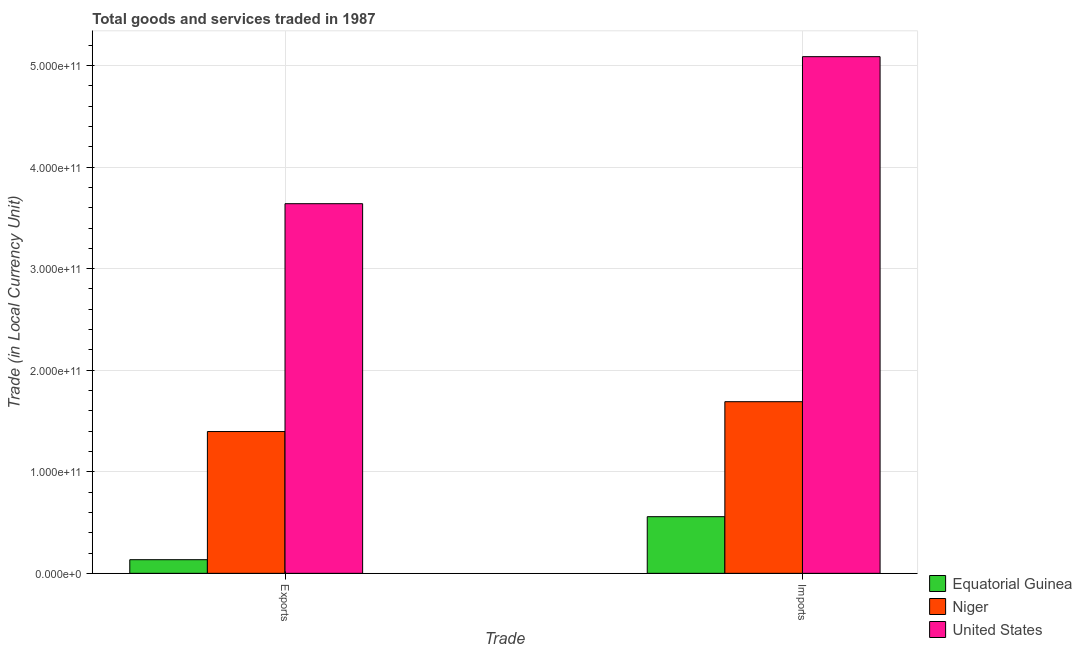Are the number of bars per tick equal to the number of legend labels?
Make the answer very short. Yes. Are the number of bars on each tick of the X-axis equal?
Offer a very short reply. Yes. How many bars are there on the 1st tick from the left?
Give a very brief answer. 3. How many bars are there on the 2nd tick from the right?
Ensure brevity in your answer.  3. What is the label of the 2nd group of bars from the left?
Your response must be concise. Imports. What is the imports of goods and services in United States?
Offer a very short reply. 5.09e+11. Across all countries, what is the maximum export of goods and services?
Provide a short and direct response. 3.64e+11. Across all countries, what is the minimum export of goods and services?
Your response must be concise. 1.34e+1. In which country was the imports of goods and services maximum?
Your answer should be compact. United States. In which country was the imports of goods and services minimum?
Offer a terse response. Equatorial Guinea. What is the total imports of goods and services in the graph?
Your answer should be compact. 7.33e+11. What is the difference between the export of goods and services in Equatorial Guinea and that in United States?
Provide a succinct answer. -3.51e+11. What is the difference between the export of goods and services in Equatorial Guinea and the imports of goods and services in Niger?
Make the answer very short. -1.56e+11. What is the average imports of goods and services per country?
Provide a succinct answer. 2.44e+11. What is the difference between the imports of goods and services and export of goods and services in United States?
Your answer should be compact. 1.45e+11. What is the ratio of the export of goods and services in Equatorial Guinea to that in Niger?
Your response must be concise. 0.1. Is the imports of goods and services in United States less than that in Niger?
Offer a terse response. No. In how many countries, is the export of goods and services greater than the average export of goods and services taken over all countries?
Provide a succinct answer. 1. What does the 1st bar from the left in Exports represents?
Ensure brevity in your answer.  Equatorial Guinea. What does the 2nd bar from the right in Exports represents?
Ensure brevity in your answer.  Niger. What is the difference between two consecutive major ticks on the Y-axis?
Give a very brief answer. 1.00e+11. Does the graph contain any zero values?
Ensure brevity in your answer.  No. Does the graph contain grids?
Make the answer very short. Yes. Where does the legend appear in the graph?
Give a very brief answer. Bottom right. How many legend labels are there?
Your answer should be very brief. 3. What is the title of the graph?
Your answer should be compact. Total goods and services traded in 1987. What is the label or title of the X-axis?
Provide a succinct answer. Trade. What is the label or title of the Y-axis?
Ensure brevity in your answer.  Trade (in Local Currency Unit). What is the Trade (in Local Currency Unit) in Equatorial Guinea in Exports?
Make the answer very short. 1.34e+1. What is the Trade (in Local Currency Unit) in Niger in Exports?
Give a very brief answer. 1.40e+11. What is the Trade (in Local Currency Unit) in United States in Exports?
Keep it short and to the point. 3.64e+11. What is the Trade (in Local Currency Unit) of Equatorial Guinea in Imports?
Ensure brevity in your answer.  5.58e+1. What is the Trade (in Local Currency Unit) of Niger in Imports?
Your answer should be very brief. 1.69e+11. What is the Trade (in Local Currency Unit) in United States in Imports?
Ensure brevity in your answer.  5.09e+11. Across all Trade, what is the maximum Trade (in Local Currency Unit) in Equatorial Guinea?
Keep it short and to the point. 5.58e+1. Across all Trade, what is the maximum Trade (in Local Currency Unit) in Niger?
Your response must be concise. 1.69e+11. Across all Trade, what is the maximum Trade (in Local Currency Unit) in United States?
Your answer should be very brief. 5.09e+11. Across all Trade, what is the minimum Trade (in Local Currency Unit) of Equatorial Guinea?
Make the answer very short. 1.34e+1. Across all Trade, what is the minimum Trade (in Local Currency Unit) in Niger?
Your answer should be very brief. 1.40e+11. Across all Trade, what is the minimum Trade (in Local Currency Unit) in United States?
Ensure brevity in your answer.  3.64e+11. What is the total Trade (in Local Currency Unit) in Equatorial Guinea in the graph?
Make the answer very short. 6.92e+1. What is the total Trade (in Local Currency Unit) in Niger in the graph?
Make the answer very short. 3.09e+11. What is the total Trade (in Local Currency Unit) in United States in the graph?
Provide a short and direct response. 8.73e+11. What is the difference between the Trade (in Local Currency Unit) in Equatorial Guinea in Exports and that in Imports?
Provide a succinct answer. -4.24e+1. What is the difference between the Trade (in Local Currency Unit) in Niger in Exports and that in Imports?
Provide a short and direct response. -2.94e+1. What is the difference between the Trade (in Local Currency Unit) of United States in Exports and that in Imports?
Provide a short and direct response. -1.45e+11. What is the difference between the Trade (in Local Currency Unit) in Equatorial Guinea in Exports and the Trade (in Local Currency Unit) in Niger in Imports?
Your response must be concise. -1.56e+11. What is the difference between the Trade (in Local Currency Unit) of Equatorial Guinea in Exports and the Trade (in Local Currency Unit) of United States in Imports?
Keep it short and to the point. -4.95e+11. What is the difference between the Trade (in Local Currency Unit) of Niger in Exports and the Trade (in Local Currency Unit) of United States in Imports?
Your response must be concise. -3.69e+11. What is the average Trade (in Local Currency Unit) of Equatorial Guinea per Trade?
Keep it short and to the point. 3.46e+1. What is the average Trade (in Local Currency Unit) in Niger per Trade?
Make the answer very short. 1.54e+11. What is the average Trade (in Local Currency Unit) of United States per Trade?
Your response must be concise. 4.36e+11. What is the difference between the Trade (in Local Currency Unit) in Equatorial Guinea and Trade (in Local Currency Unit) in Niger in Exports?
Your response must be concise. -1.26e+11. What is the difference between the Trade (in Local Currency Unit) in Equatorial Guinea and Trade (in Local Currency Unit) in United States in Exports?
Your answer should be very brief. -3.51e+11. What is the difference between the Trade (in Local Currency Unit) of Niger and Trade (in Local Currency Unit) of United States in Exports?
Your answer should be compact. -2.24e+11. What is the difference between the Trade (in Local Currency Unit) in Equatorial Guinea and Trade (in Local Currency Unit) in Niger in Imports?
Offer a very short reply. -1.13e+11. What is the difference between the Trade (in Local Currency Unit) in Equatorial Guinea and Trade (in Local Currency Unit) in United States in Imports?
Offer a terse response. -4.53e+11. What is the difference between the Trade (in Local Currency Unit) of Niger and Trade (in Local Currency Unit) of United States in Imports?
Keep it short and to the point. -3.40e+11. What is the ratio of the Trade (in Local Currency Unit) of Equatorial Guinea in Exports to that in Imports?
Make the answer very short. 0.24. What is the ratio of the Trade (in Local Currency Unit) of Niger in Exports to that in Imports?
Provide a short and direct response. 0.83. What is the ratio of the Trade (in Local Currency Unit) in United States in Exports to that in Imports?
Offer a terse response. 0.72. What is the difference between the highest and the second highest Trade (in Local Currency Unit) of Equatorial Guinea?
Offer a terse response. 4.24e+1. What is the difference between the highest and the second highest Trade (in Local Currency Unit) in Niger?
Give a very brief answer. 2.94e+1. What is the difference between the highest and the second highest Trade (in Local Currency Unit) in United States?
Your answer should be compact. 1.45e+11. What is the difference between the highest and the lowest Trade (in Local Currency Unit) of Equatorial Guinea?
Your answer should be very brief. 4.24e+1. What is the difference between the highest and the lowest Trade (in Local Currency Unit) in Niger?
Your answer should be very brief. 2.94e+1. What is the difference between the highest and the lowest Trade (in Local Currency Unit) of United States?
Make the answer very short. 1.45e+11. 